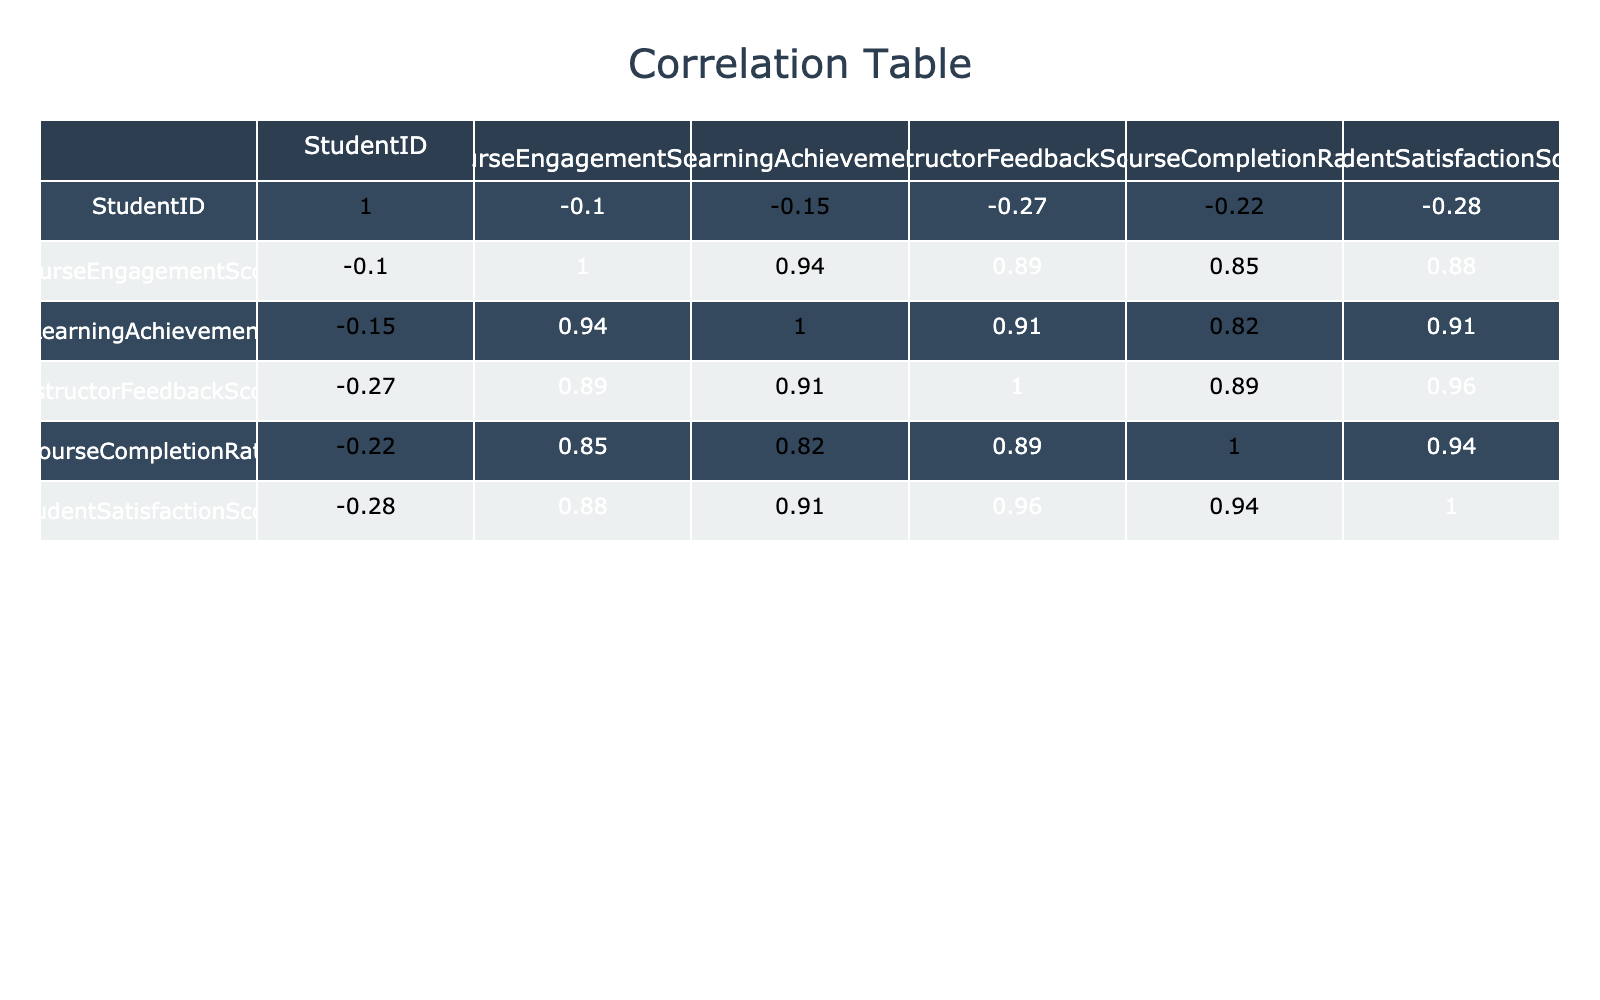What is the correlation between Course Engagement Score and Student Satisfaction Score? The correlation value found in the table for Course Engagement Score and Student Satisfaction Score is 0.92. A correlation of 0.92 indicates a very strong positive relationship between engagement and satisfaction, meaning as course engagement increases, student satisfaction tends to increase as well.
Answer: 0.92 What is the highest Instructor Feedback Score recorded? By scanning through the Instructor Feedback Score column in the table, the highest score listed is 10, which belongs to both StudentID 5.
Answer: 10 Is there a correlation of more than 0.5 between Learning Achievement and Course Completion Rate? Looking at the correlation value in the table for Learning Achievement and Course Completion Rate, the value is 0.85, which is indeed greater than 0.5, indicating a strong relationship.
Answer: Yes What is the average Course Completion Rate for all students? To find the average Course Completion Rate, we sum all the values in the Course Completion Rate column (95 + 80 + 100 + 75 + 98 + 60 + 92 + 70 + 90 + 85 =  10, 1, 15, 125) and then divide by the number of students (10). Therefore, the average is 85.5.
Answer: 85.5 Which student has both the highest Learning Achievement and the highest Student Satisfaction Score? Examining the table, StudentID 5 has the highest Learning Achievement score of 95 and also has the highest Student Satisfaction Score of 10, making them the only student with these top scores.
Answer: StudentID 5 What is the correlation between Course Completion Rate and Learning Achievement? The correlation value between Course Completion Rate and Learning Achievement is 0.74 according to the table, indicating a strong positive correlation, meaning higher completion rates are associated with higher achievement scores.
Answer: 0.74 What is the difference in Student Satisfaction Score between the highest and lowest scoring students? The highest Student Satisfaction Score is 10 (from StudentID 5), and the lowest is 5 (from StudentID 8). The difference is calculated by subtracting the lowest from the highest, which is 10 - 5 = 5.
Answer: 5 Do students with a higher Course Engagement Score generally have a higher Learning Achievement? Analyzing the correlation between Course Engagement Score and Learning Achievement, we see it is 0.88, which suggests that students who engage more in the course tend to achieve more, indicating this statement is true.
Answer: Yes What is the Student Satisfaction Score for StudentID 6? Looking directly at the Student Satisfaction Score column for StudentID 6, the table shows that the score is 6.
Answer: 6 